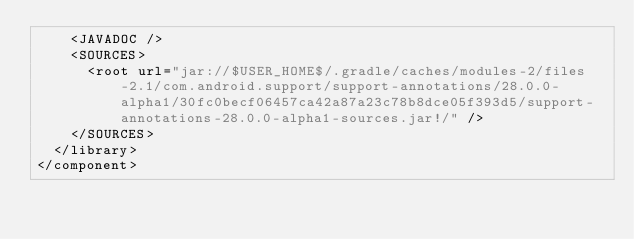Convert code to text. <code><loc_0><loc_0><loc_500><loc_500><_XML_>    <JAVADOC />
    <SOURCES>
      <root url="jar://$USER_HOME$/.gradle/caches/modules-2/files-2.1/com.android.support/support-annotations/28.0.0-alpha1/30fc0becf06457ca42a87a23c78b8dce05f393d5/support-annotations-28.0.0-alpha1-sources.jar!/" />
    </SOURCES>
  </library>
</component></code> 